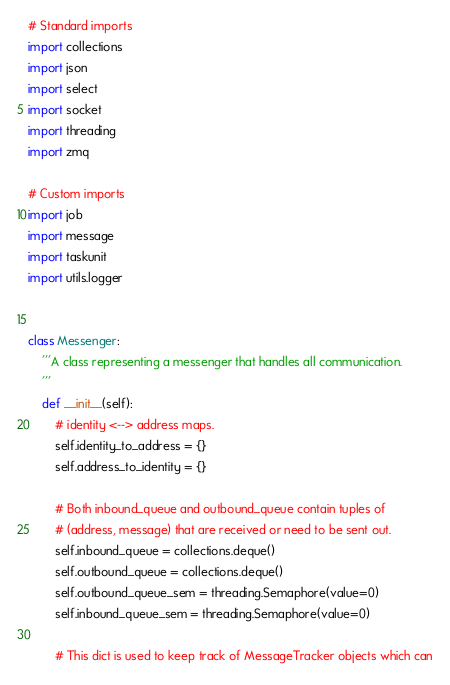<code> <loc_0><loc_0><loc_500><loc_500><_Python_># Standard imports
import collections
import json
import select
import socket
import threading
import zmq

# Custom imports
import job
import message
import taskunit
import utils.logger


class Messenger:
    '''A class representing a messenger that handles all communication.
    '''
    def __init__(self):
        # identity <--> address maps.
        self.identity_to_address = {}
        self.address_to_identity = {}

        # Both inbound_queue and outbound_queue contain tuples of
        # (address, message) that are received or need to be sent out.
        self.inbound_queue = collections.deque()
        self.outbound_queue = collections.deque()
        self.outbound_queue_sem = threading.Semaphore(value=0)
        self.inbound_queue_sem = threading.Semaphore(value=0)

        # This dict is used to keep track of MessageTracker objects which can</code> 